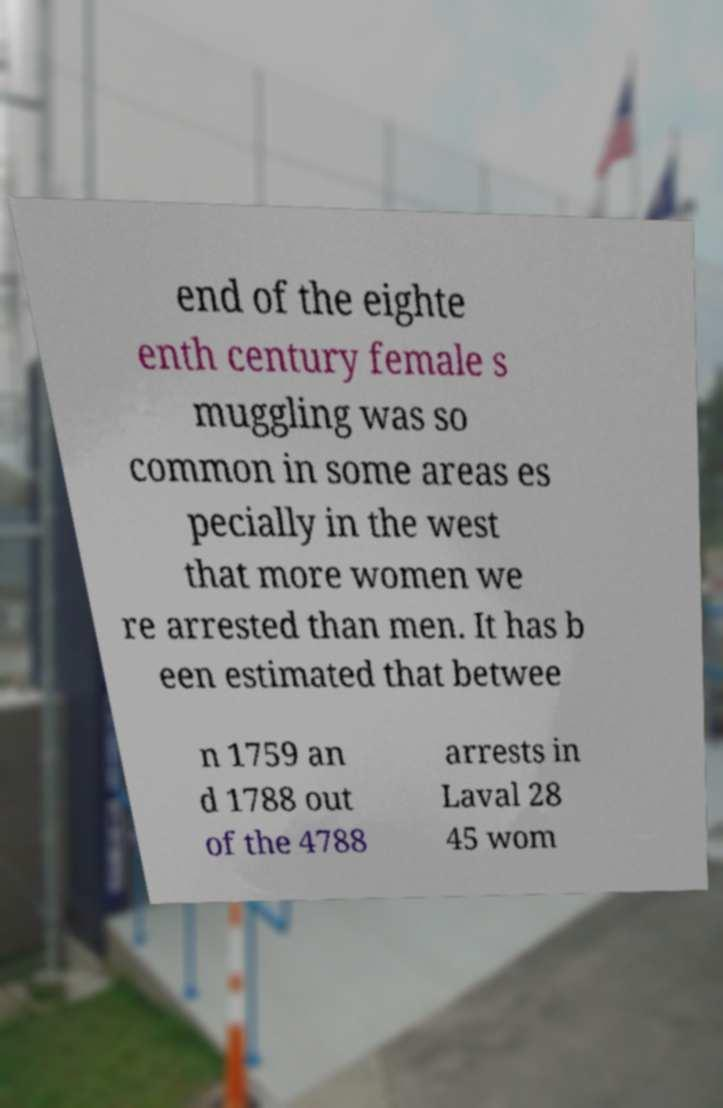Can you accurately transcribe the text from the provided image for me? end of the eighte enth century female s muggling was so common in some areas es pecially in the west that more women we re arrested than men. It has b een estimated that betwee n 1759 an d 1788 out of the 4788 arrests in Laval 28 45 wom 